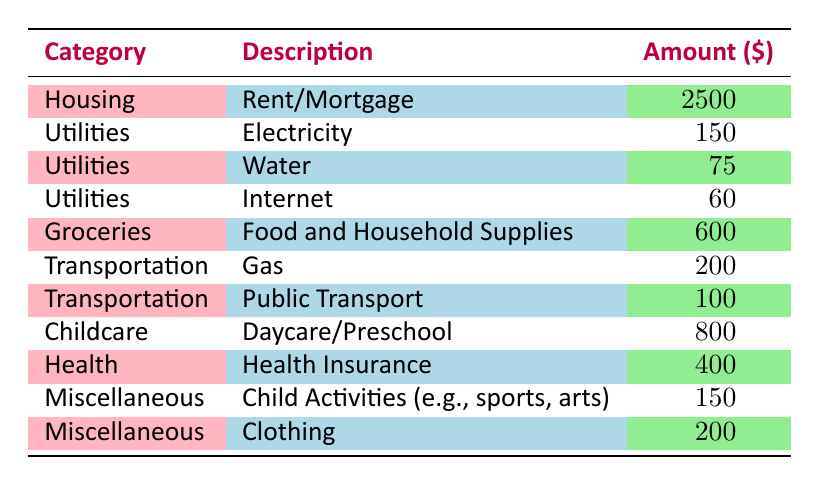What is the total amount spent on Housing? The table shows that the Amount for Housing (Rent/Mortgage) is 2500. Therefore, the total amount spent on Housing is simply this value.
Answer: 2500 What are the total Utilities expenses? The Utilities expenses are broken down into three categories: Electricity (150), Water (75), and Internet (60). Summing these amounts gives us 150 + 75 + 60 = 285.
Answer: 285 Is the monthly expense for Childcare greater than the expense for Health? The Childcare expense for Daycare/Preschool is 800, while the Health expense for Health Insurance is 400. Since 800 is greater than 400, the statement is true.
Answer: Yes What is the combined total for Groceries and Childcare expenses? The Groceries expense for Food and Household Supplies is 600, while the Childcare expense is 800. Adding these two amounts: 600 + 800 = 1400 gives us the combined total.
Answer: 1400 How much does the family spend on Transportation as compared to Utilities? The Transportation expenses are Gas (200) and Public Transport (100), totaling 200 + 100 = 300. The total Utilities expenses are 285. Since 300 is greater than 285, the family spends more on Transportation than Utilities.
Answer: Yes What is the average amount spent per category? There are 11 expense categories listed in the table. The total expenses sum up to 4060 (which is 2500 + 150 + 75 + 60 + 600 + 200 + 100 + 800 + 400 + 150 + 200 = 4060). Dividing this total by the number of categories gives us 4060 / 11 = approx. 369.09.
Answer: 369.09 How much does the family spend on Miscellaneous activities? The Miscellaneous expenses include Child Activities (150) and Clothing (200). Adding these gives us 150 + 200 = 350, hence the total for Miscellaneous activities is 350.
Answer: 350 Which category has the highest individual expense? The highest individual expense is found in Housing, where the expense for Rent/Mortgage is 2500. None of the other categories have an amount that exceeds this value.
Answer: 2500 What is the total spent on essential services (Utilities and Health)? The Utilities expenses add up to 285, and the Health expense is 400. Together, the total for essential services is 285 + 400 = 685.
Answer: 685 